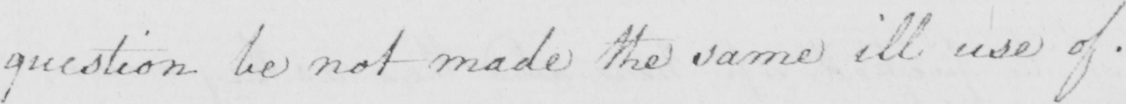Transcribe the text shown in this historical manuscript line. question be not made the same ill use of . 